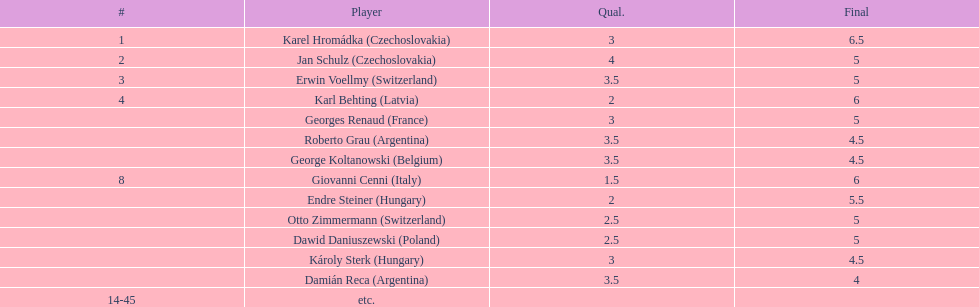How many countries had at least two players competing in the consolation cup? 4. 